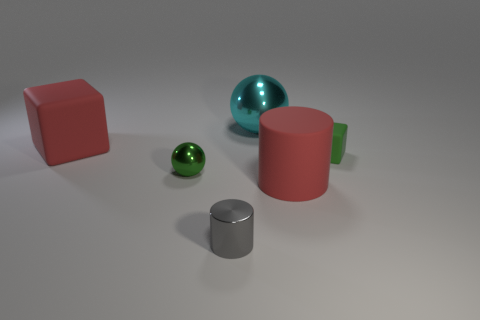There is a shiny thing in front of the red object in front of the green object that is to the left of the green rubber object; what color is it?
Provide a short and direct response. Gray. Does the big cube behind the gray metallic cylinder have the same material as the big red cylinder?
Your response must be concise. Yes. What number of other objects are there of the same material as the tiny green sphere?
Give a very brief answer. 2. There is a gray object that is the same size as the green metal thing; what is its material?
Offer a very short reply. Metal. There is a large red thing that is left of the big metallic thing; does it have the same shape as the small metallic object in front of the tiny green metal object?
Keep it short and to the point. No. What shape is the green metallic thing that is the same size as the gray shiny thing?
Your response must be concise. Sphere. Are the sphere that is behind the tiny green cube and the large red thing left of the small shiny cylinder made of the same material?
Offer a very short reply. No. Is there a small green block that is in front of the block that is to the right of the large metal ball?
Ensure brevity in your answer.  No. What color is the large ball that is the same material as the tiny cylinder?
Give a very brief answer. Cyan. Is the number of big purple shiny cylinders greater than the number of red cubes?
Offer a very short reply. No. 